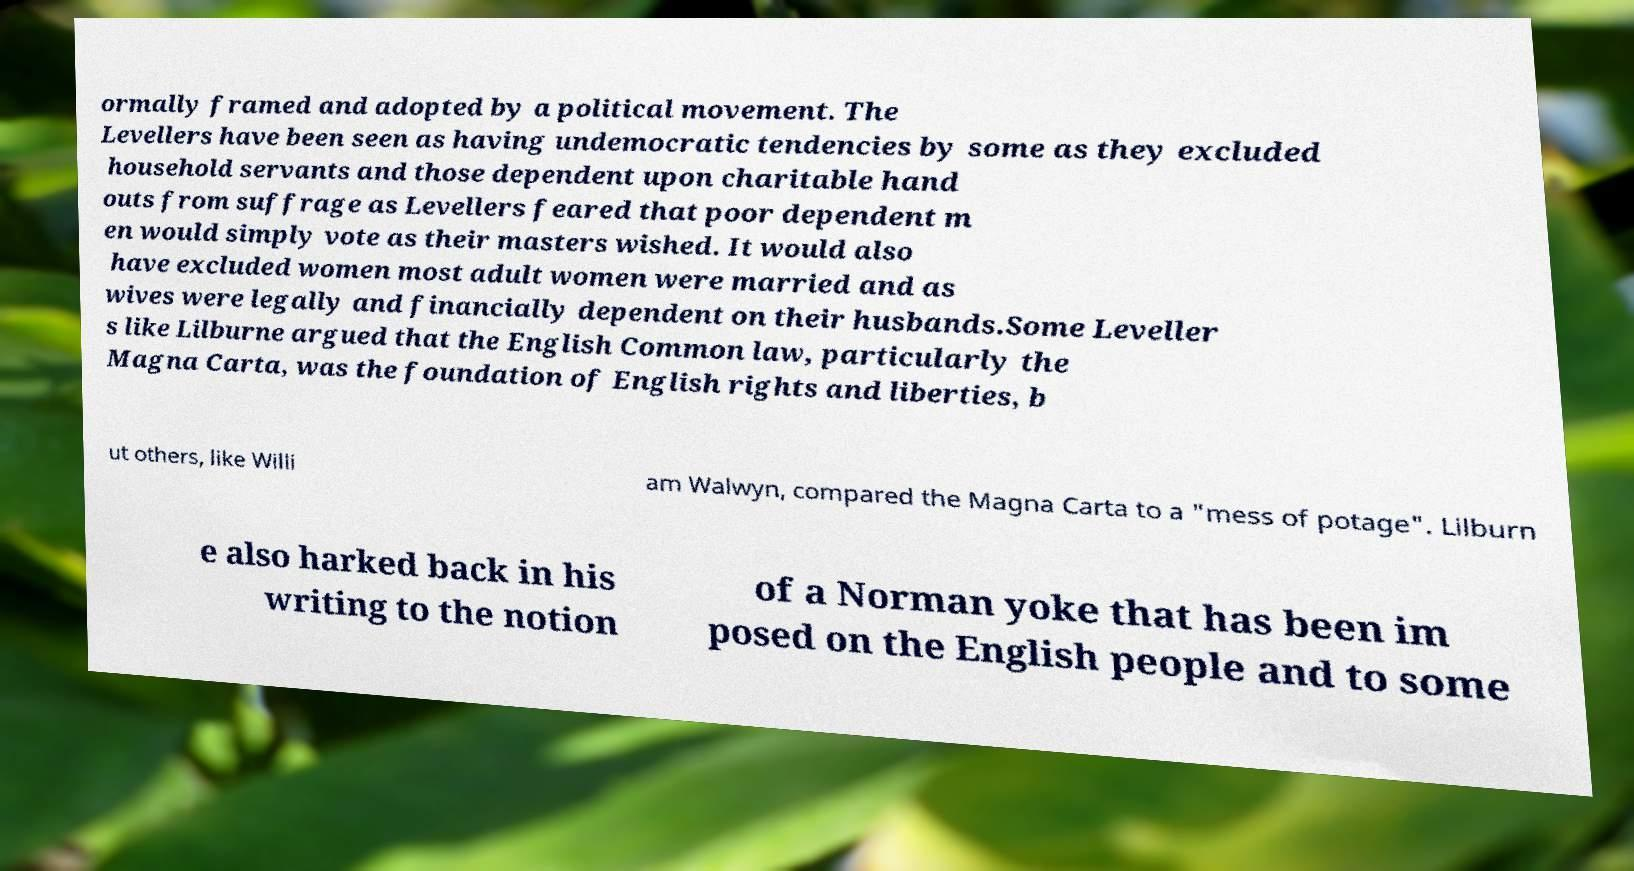For documentation purposes, I need the text within this image transcribed. Could you provide that? ormally framed and adopted by a political movement. The Levellers have been seen as having undemocratic tendencies by some as they excluded household servants and those dependent upon charitable hand outs from suffrage as Levellers feared that poor dependent m en would simply vote as their masters wished. It would also have excluded women most adult women were married and as wives were legally and financially dependent on their husbands.Some Leveller s like Lilburne argued that the English Common law, particularly the Magna Carta, was the foundation of English rights and liberties, b ut others, like Willi am Walwyn, compared the Magna Carta to a "mess of potage". Lilburn e also harked back in his writing to the notion of a Norman yoke that has been im posed on the English people and to some 